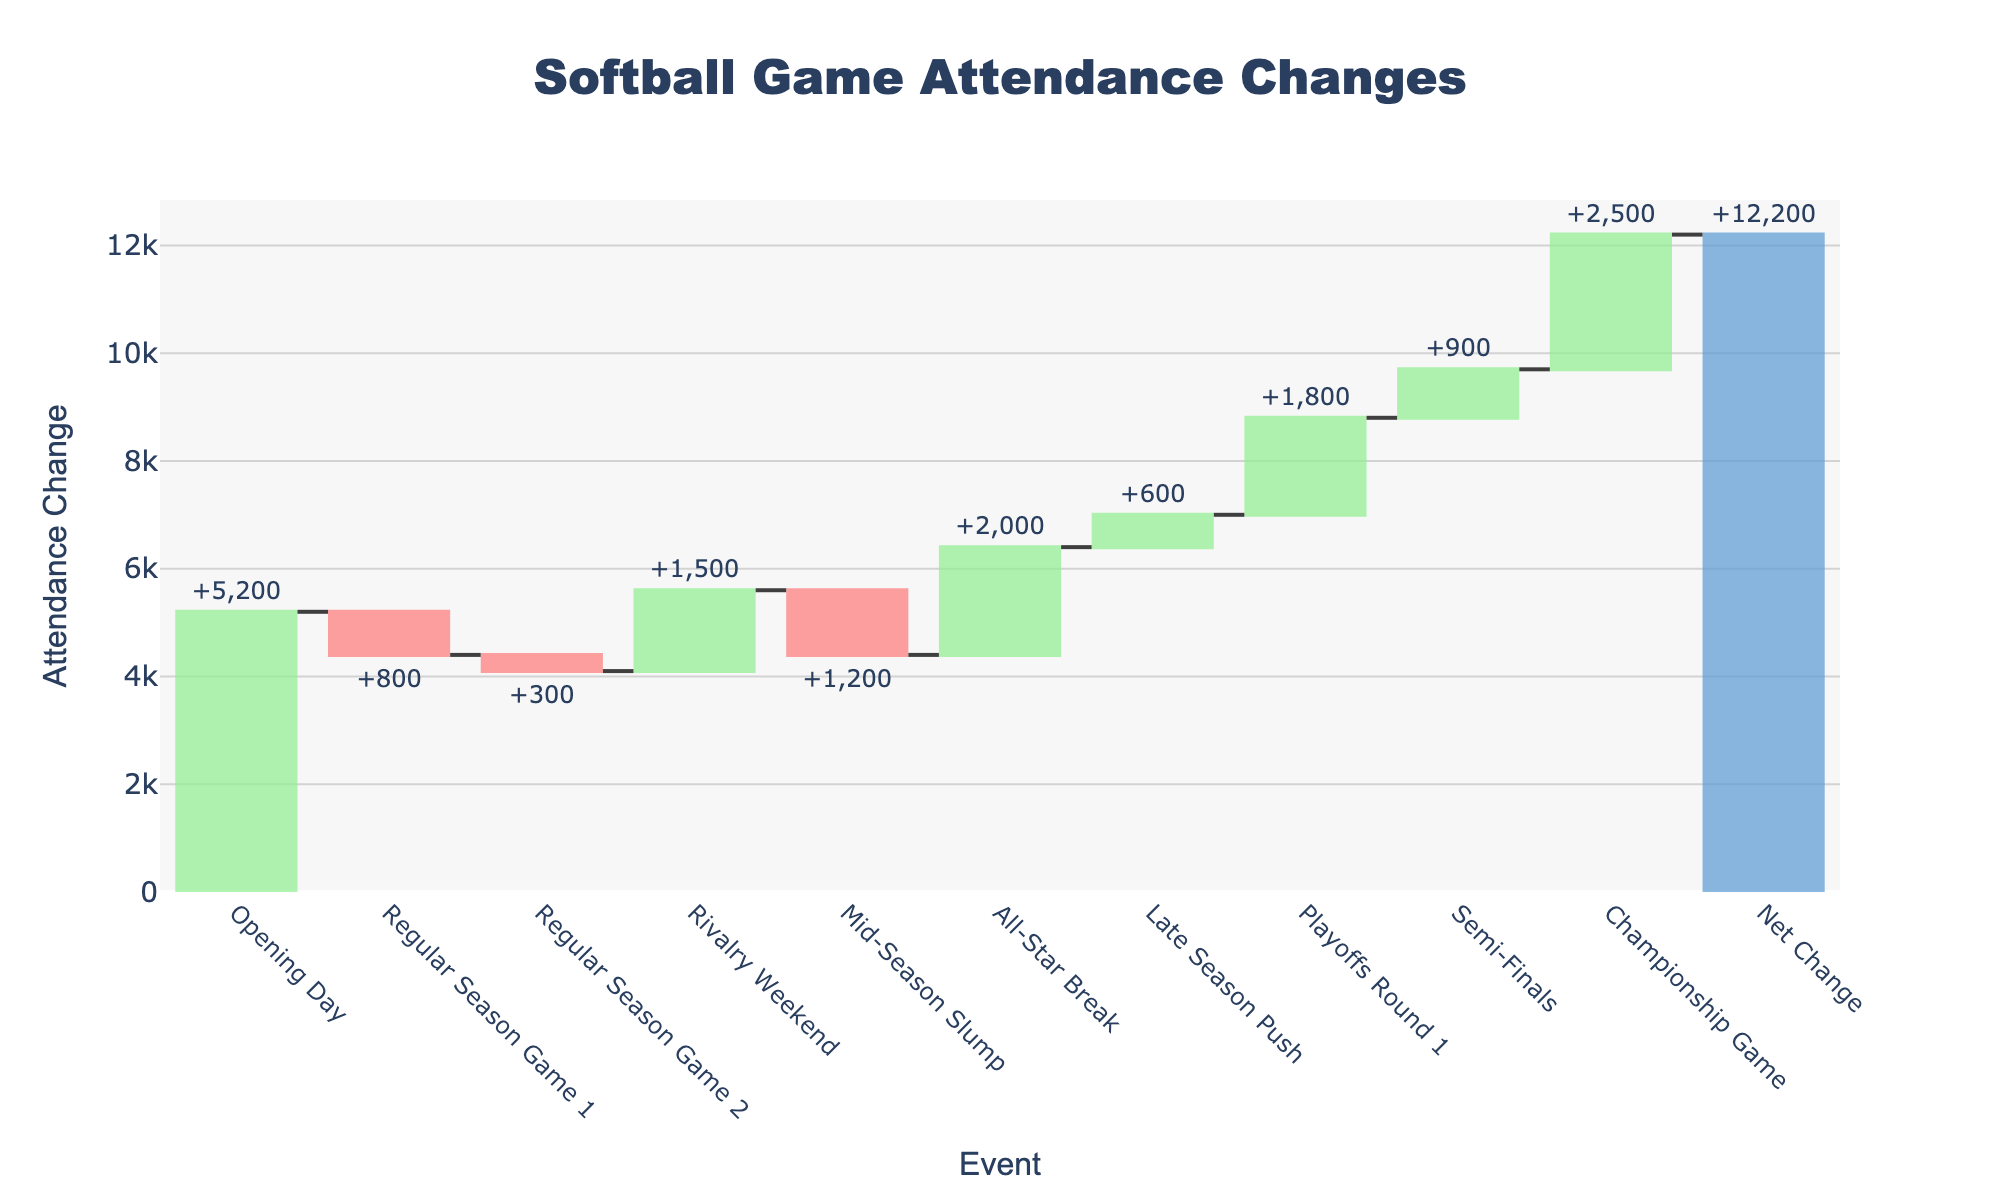What is the title of the figure? The title of the figure is generally located at the top and is a descriptive summary of what the figure represents. Here, the title at the top center of the figure reads "Softball Game Attendance Changes".
Answer: Softball Game Attendance Changes How many events are depicted in the chart, excluding the net change? By counting the number of unique event names along the x-axis of the chart before the "Net Change" label, we can see there are 10 events.
Answer: 10 Which event had the highest increase in attendance? By observing the bars that extend upwards (increasing values) and identifying the one with the greatest height, we see that the event with the "+2500" label (Championship Game) had the highest increase.
Answer: Championship Game Which event had the largest decrease in attendance? By looking for the largest downward bar (negative value), we find that the event labeled "-1200" (Mid-Season Slump) had the largest decrease in attendance.
Answer: Mid-Season Slump What is the net change in attendance from opening day to the championship game? The net change can be found in the "Net Change" bar at the end. This bar sums up all increases and decreases in attendance over the season. The label on this bar shows the total change in attendance, which is +12200.
Answer: +12200 How does the attendance change during Mid-Season Slump compare to Regular Season Game 3? The attendance change for Mid-Season Slump is "-1200" and for Regular Season Game 3 is "-300". Comparing these values shows that the Mid-Season Slump had a larger negative change in attendance.
Answer: Mid-Season Slump had a larger decrease What was the attendance change during the Playoffs Round 1? Referring to the bar labeled "Playoffs Round 1", we see an attendance change of "+1800".
Answer: +1800 How many events resulted in a positive attendance change? Identify and count the upward (green) bars: Opening Day, Rivalry Weekend, All-Star Break, Late Season Push, Playoffs Round 1, Semi-Finals, and Championship Game. Thus, there are 7 events with a positive change.
Answer: 7 What is the cumulative attendance change by the end of Regular Season Game 2? To find this, sum the changes up to and including Regular Season Game 2: +5200 - 800 - 300 = +4100.
Answer: +4100 